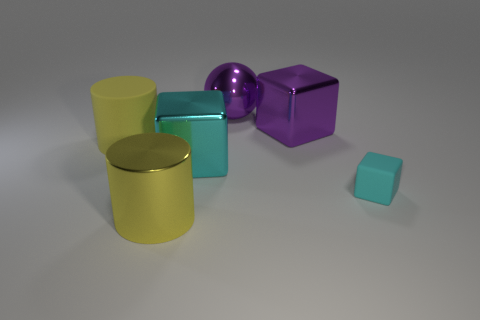Is there any interaction between the objects that suggests a certain theme or narrative? The objects do not interact directly, but their placement and varying sizes could imply a narrative about scale and perspective, or perhaps represent an abstract assembly of shapes to delight the viewer's sense of geometry and color contrast. Could these objects serve any particular purpose in a practical scenario? While they appear simplistic and decorative in this arrangement, these shapes could be interpreted as models for design elements in architecture, interior design, or even conceptual art, wherein each form and color choice could influence a space or convey certain emotions. 